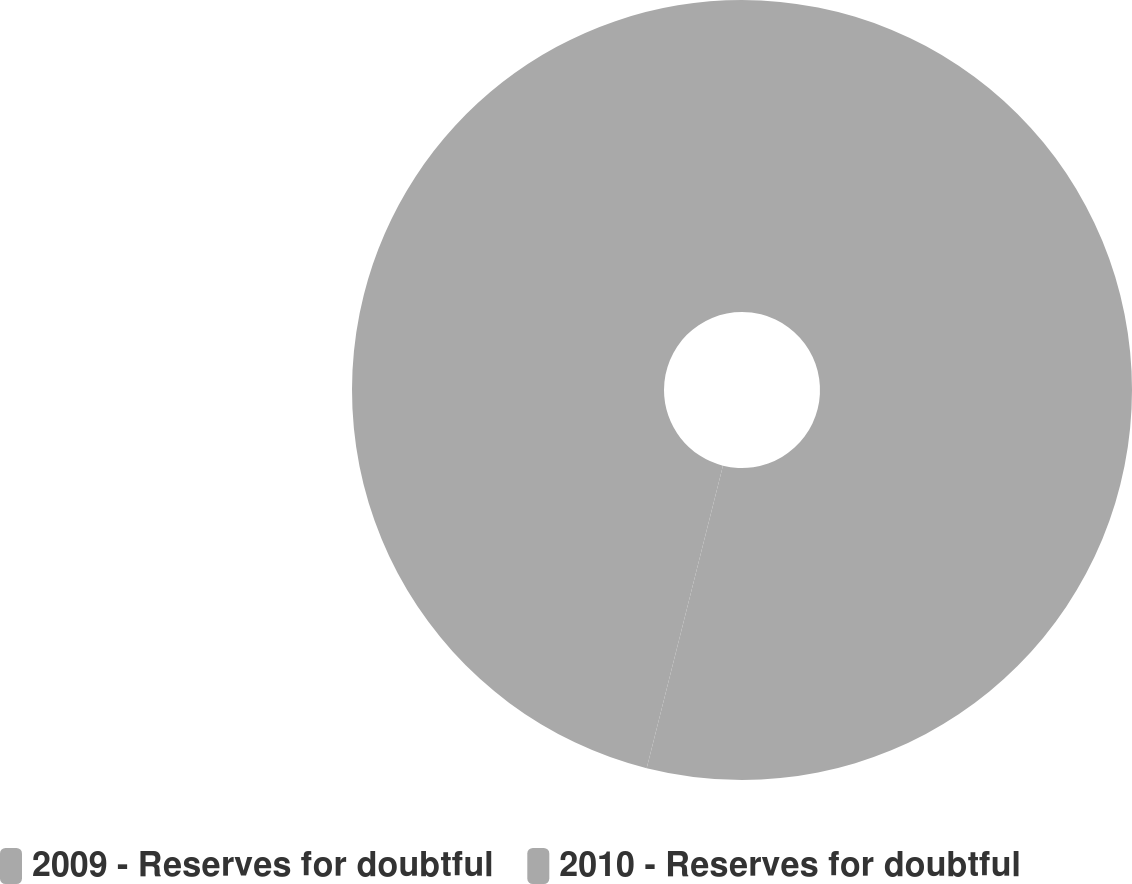Convert chart to OTSL. <chart><loc_0><loc_0><loc_500><loc_500><pie_chart><fcel>2009 - Reserves for doubtful<fcel>2010 - Reserves for doubtful<nl><fcel>53.93%<fcel>46.07%<nl></chart> 